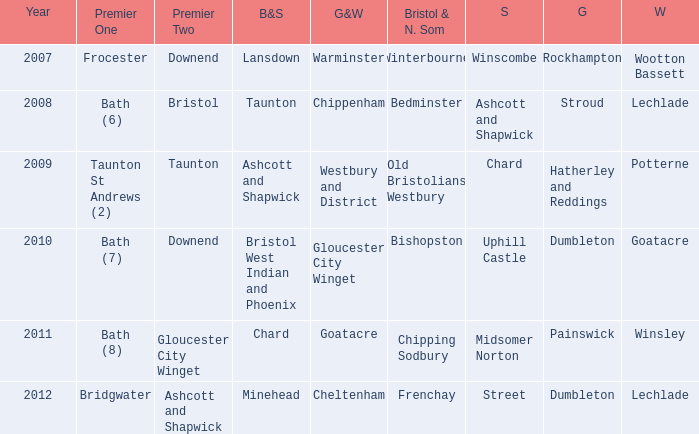What is the somerset for the  year 2009? Chard. 